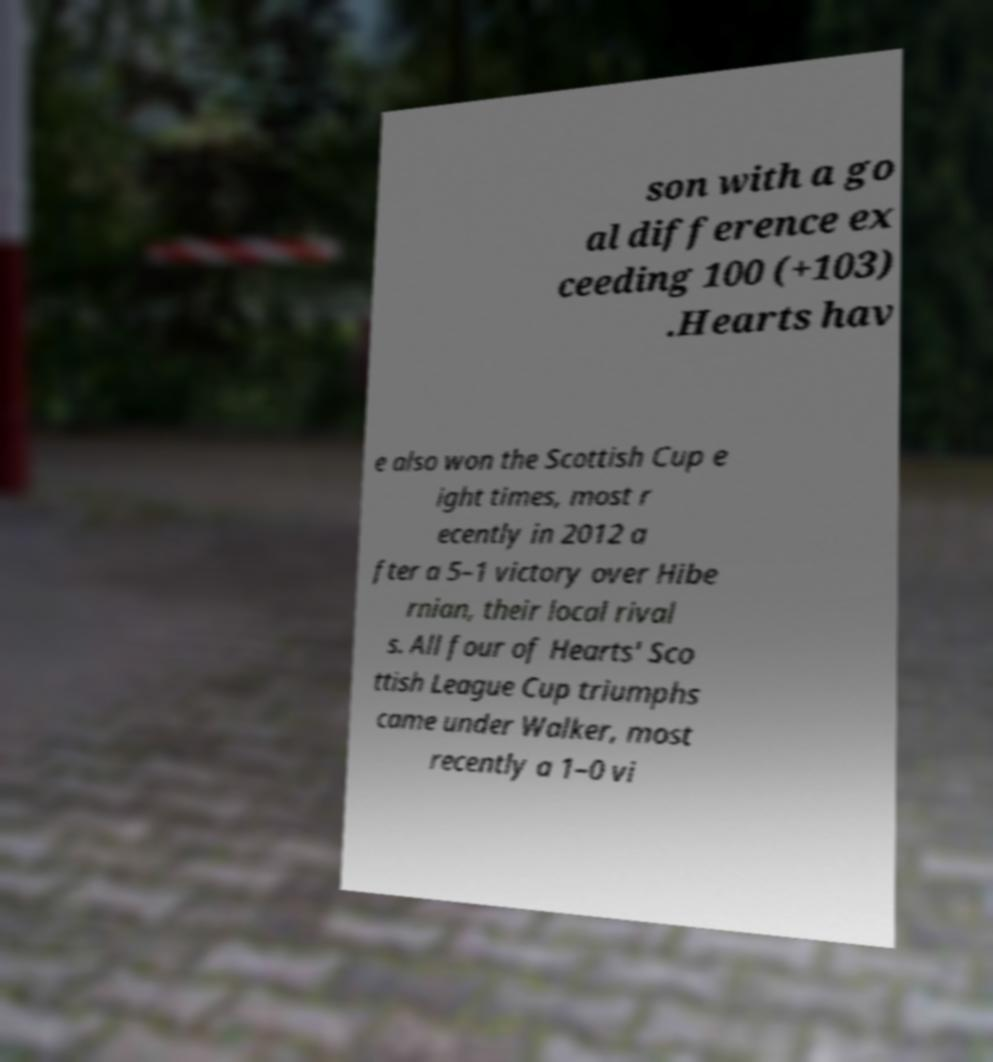For documentation purposes, I need the text within this image transcribed. Could you provide that? son with a go al difference ex ceeding 100 (+103) .Hearts hav e also won the Scottish Cup e ight times, most r ecently in 2012 a fter a 5–1 victory over Hibe rnian, their local rival s. All four of Hearts' Sco ttish League Cup triumphs came under Walker, most recently a 1–0 vi 